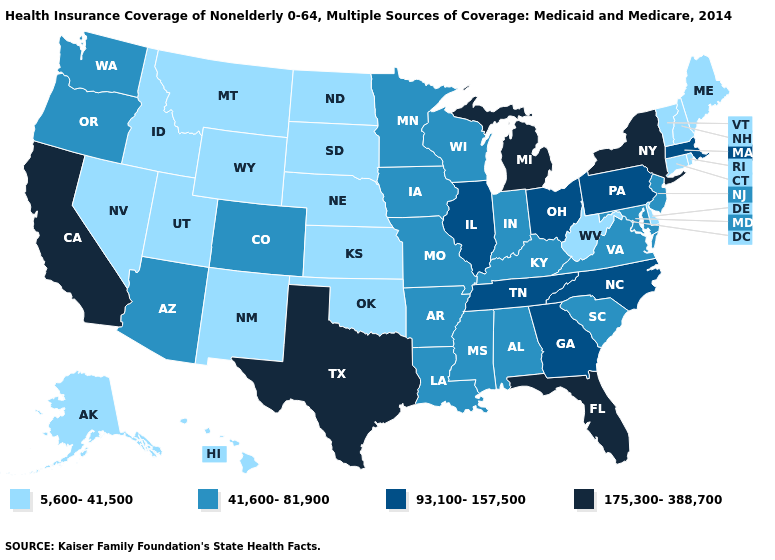Does the map have missing data?
Give a very brief answer. No. What is the value of Maine?
Quick response, please. 5,600-41,500. What is the value of Georgia?
Concise answer only. 93,100-157,500. Does the first symbol in the legend represent the smallest category?
Give a very brief answer. Yes. Name the states that have a value in the range 175,300-388,700?
Quick response, please. California, Florida, Michigan, New York, Texas. Which states hav the highest value in the MidWest?
Concise answer only. Michigan. What is the value of Hawaii?
Quick response, please. 5,600-41,500. What is the value of Oklahoma?
Give a very brief answer. 5,600-41,500. What is the highest value in states that border Kentucky?
Keep it brief. 93,100-157,500. How many symbols are there in the legend?
Keep it brief. 4. What is the lowest value in the Northeast?
Concise answer only. 5,600-41,500. Among the states that border North Carolina , which have the lowest value?
Short answer required. South Carolina, Virginia. Name the states that have a value in the range 5,600-41,500?
Quick response, please. Alaska, Connecticut, Delaware, Hawaii, Idaho, Kansas, Maine, Montana, Nebraska, Nevada, New Hampshire, New Mexico, North Dakota, Oklahoma, Rhode Island, South Dakota, Utah, Vermont, West Virginia, Wyoming. What is the value of Utah?
Short answer required. 5,600-41,500. 